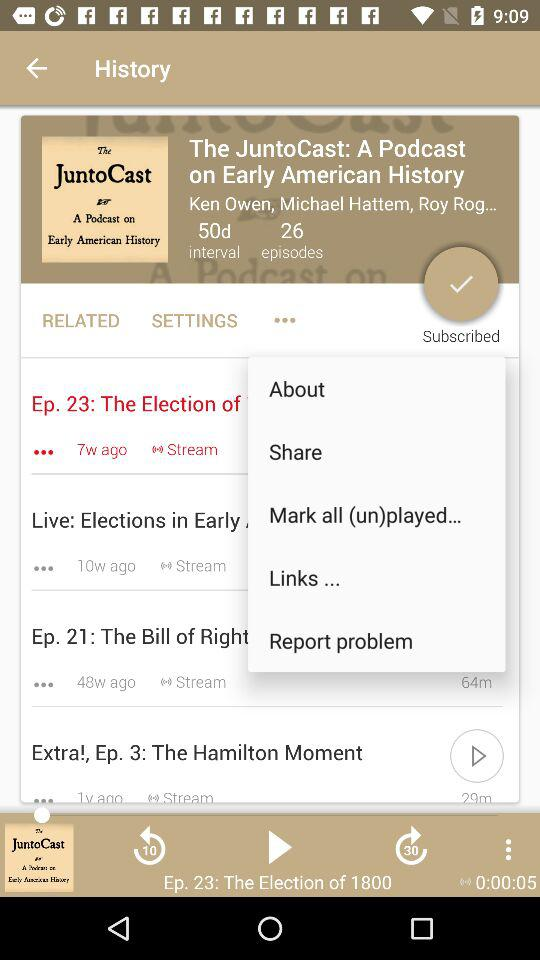What episode number was last played? The last played episode number was 23. 